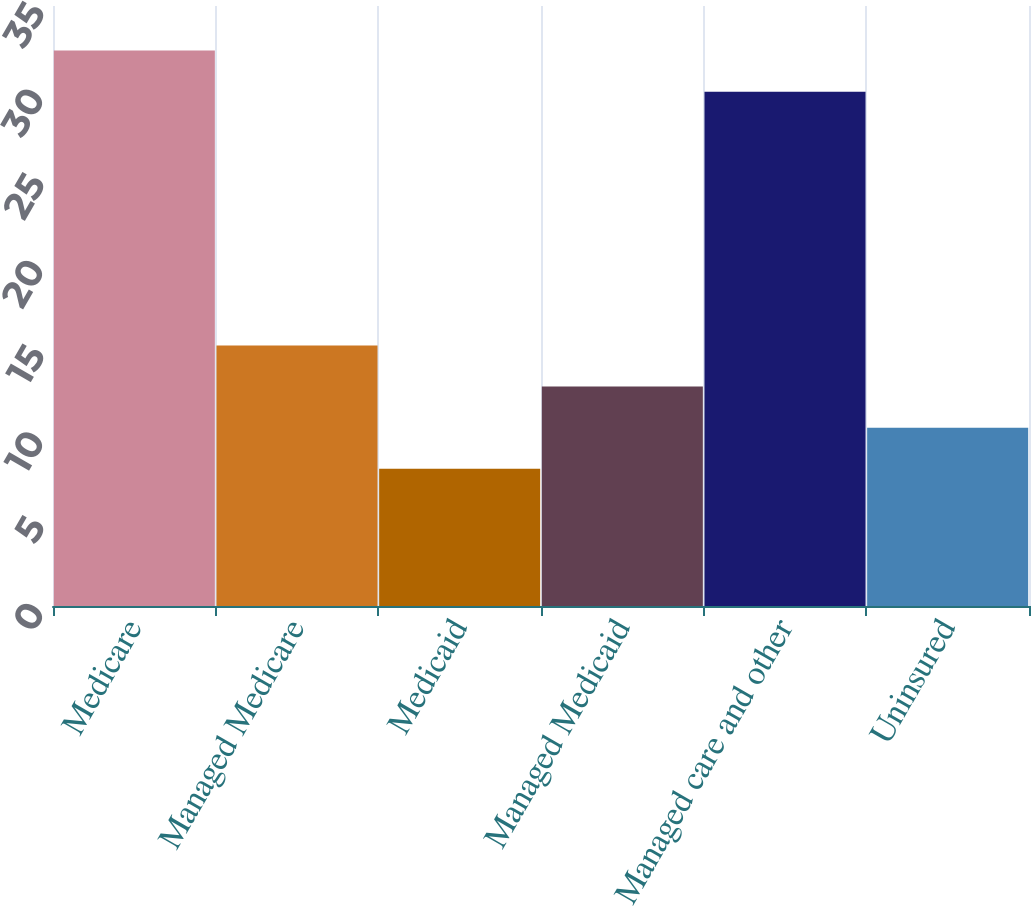<chart> <loc_0><loc_0><loc_500><loc_500><bar_chart><fcel>Medicare<fcel>Managed Medicare<fcel>Medicaid<fcel>Managed Medicaid<fcel>Managed care and other<fcel>Uninsured<nl><fcel>32.4<fcel>15.2<fcel>8<fcel>12.8<fcel>30<fcel>10.4<nl></chart> 